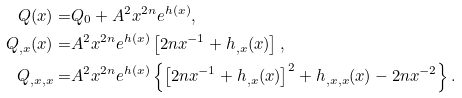<formula> <loc_0><loc_0><loc_500><loc_500>Q ( x ) = & Q _ { 0 } + A ^ { 2 } x ^ { 2 n } e ^ { h ( x ) } , \\ Q _ { , x } ( x ) = & A ^ { 2 } x ^ { 2 n } e ^ { h ( x ) } \left [ 2 n x ^ { - 1 } + h _ { , x } ( x ) \right ] , \\ Q _ { , x , x } = & A ^ { 2 } x ^ { 2 n } e ^ { h ( x ) } \left \{ \left [ 2 n x ^ { - 1 } + h _ { , x } ( x ) \right ] ^ { 2 } + h _ { , x , x } ( x ) - 2 n x ^ { - 2 } \right \} .</formula> 